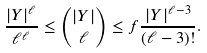<formula> <loc_0><loc_0><loc_500><loc_500>\frac { | Y | ^ { \ell } } { \ell ^ { \ell } } \leq \binom { | Y | } { \ell } \leq f \frac { | Y | ^ { \ell - 3 } } { ( \ell - 3 ) ! } .</formula> 